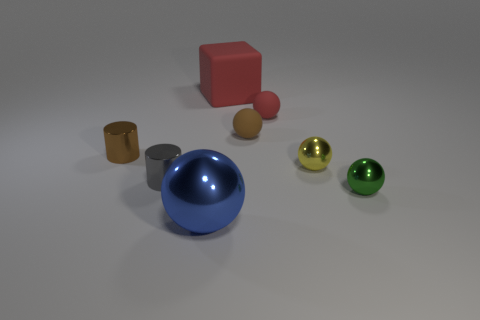What are the different colors of spheres depicted in the image? The image features spheres in three distinct colors: gold, green, and red. 